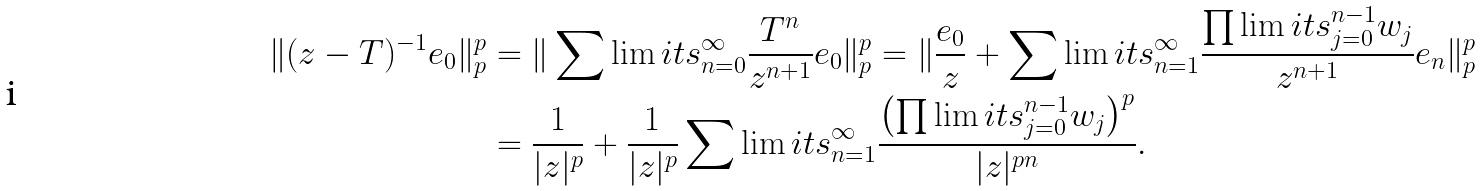Convert formula to latex. <formula><loc_0><loc_0><loc_500><loc_500>\| ( z - T ) ^ { - 1 } e _ { 0 } \| ^ { p } _ { p } & = \| \sum \lim i t s _ { n = 0 } ^ { \infty } \frac { T ^ { n } } { z ^ { n + 1 } } e _ { 0 } \| ^ { p } _ { p } = \| \frac { e _ { 0 } } { z } + \sum \lim i t s _ { n = 1 } ^ { \infty } \frac { \prod \lim i t s _ { j = 0 } ^ { n - 1 } w _ { j } } { z ^ { n + 1 } } e _ { n } \| ^ { p } _ { p } \\ & = \frac { 1 } { | z | ^ { p } } + \frac { 1 } { | z | ^ { p } } \sum \lim i t s _ { n = 1 } ^ { \infty } \frac { \left ( \prod \lim i t s _ { j = 0 } ^ { n - 1 } w _ { j } \right ) ^ { p } } { | z | ^ { p n } } .</formula> 